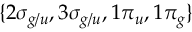<formula> <loc_0><loc_0><loc_500><loc_500>\{ 2 \sigma _ { g / u } , 3 \sigma _ { g / u } , 1 \pi _ { u } , 1 \pi _ { g } \}</formula> 